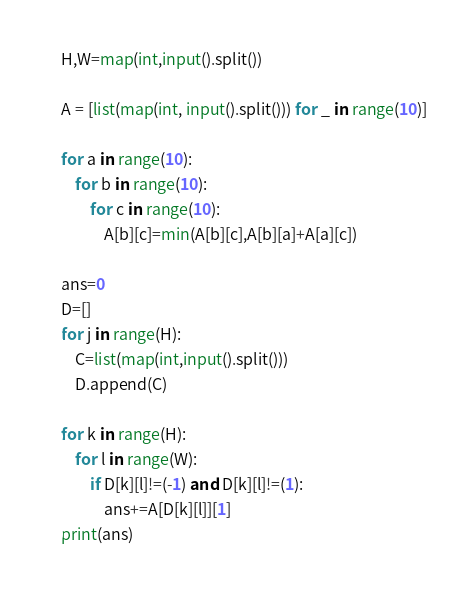<code> <loc_0><loc_0><loc_500><loc_500><_Python_>H,W=map(int,input().split())

A = [list(map(int, input().split())) for _ in range(10)]

for a in range(10):
    for b in range(10):
        for c in range(10):
            A[b][c]=min(A[b][c],A[b][a]+A[a][c])

ans=0
D=[]
for j in range(H):
    C=list(map(int,input().split()))
    D.append(C)
        
for k in range(H):
    for l in range(W):
        if D[k][l]!=(-1) and D[k][l]!=(1):
            ans+=A[D[k][l]][1]
print(ans)</code> 